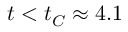<formula> <loc_0><loc_0><loc_500><loc_500>t < t _ { C } \approx 4 . 1</formula> 